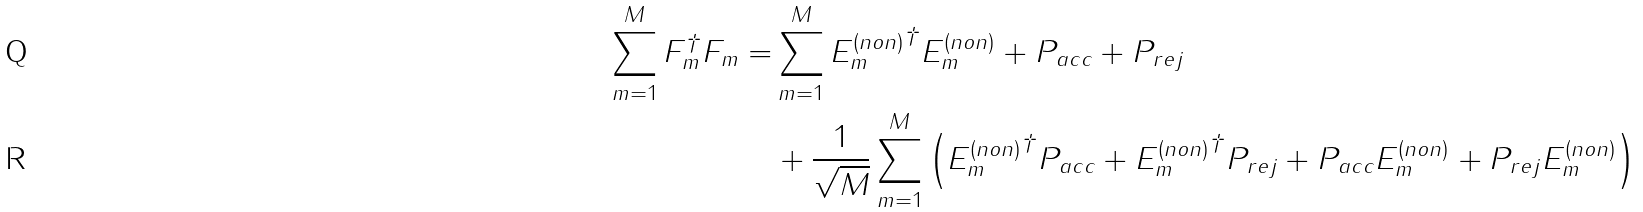<formula> <loc_0><loc_0><loc_500><loc_500>\sum _ { m = 1 } ^ { M } F _ { m } ^ { \dagger } F _ { m } = & \sum _ { m = 1 } ^ { M } { E _ { m } ^ { ( n o n ) } } ^ { \dagger } E _ { m } ^ { ( n o n ) } + P _ { a c c } + P _ { r e j } \\ & + \frac { 1 } { \sqrt { M } } \sum _ { m = 1 } ^ { M } \left ( { E _ { m } ^ { ( n o n ) } } ^ { \dagger } P _ { a c c } + { E _ { m } ^ { ( n o n ) } } ^ { \dagger } P _ { r e j } + P _ { a c c } E _ { m } ^ { ( n o n ) } + P _ { r e j } E _ { m } ^ { ( n o n ) } \right )</formula> 